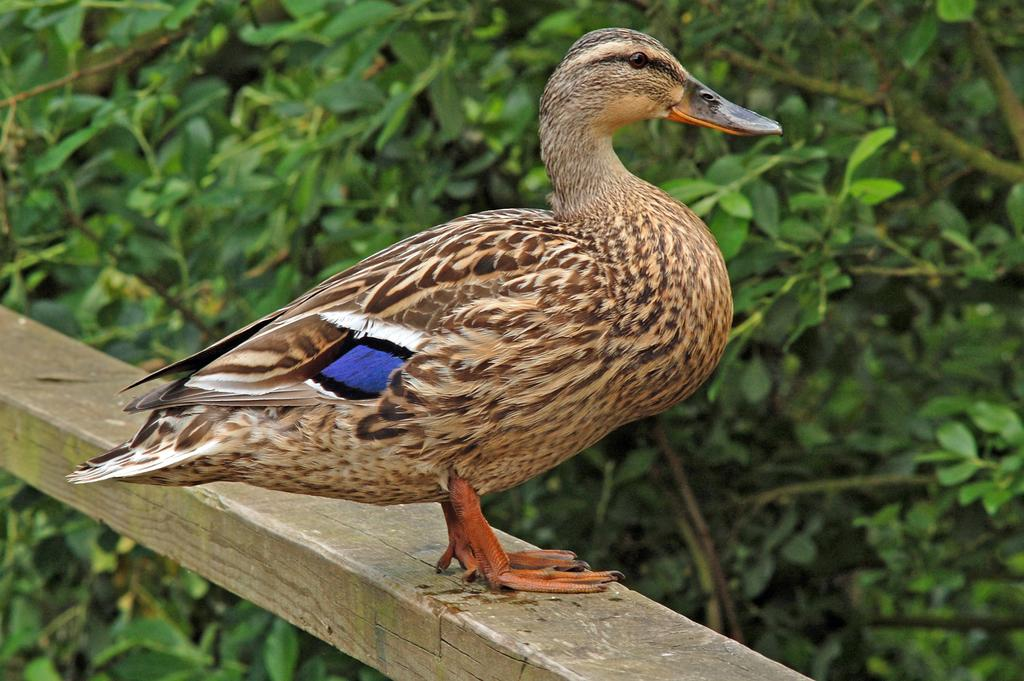What animal is present in the image? There is a duck in the image. What is the duck standing on? The duck is standing on a wooden pole. What type of vegetation can be seen in the background of the image? There are leaves and stems in the background of the image. What type of insurance does the maid in the image offer? There is no maid or insurance mentioned in the image; it features a duck standing on a wooden pole with leaves and stems in the background. 